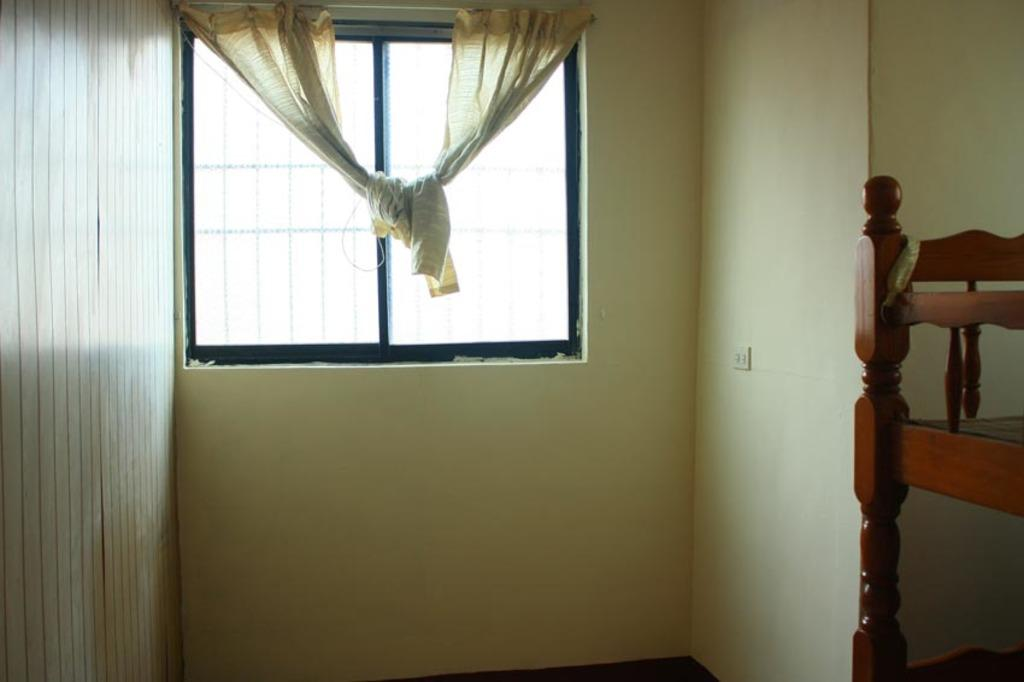What is located in the center of the image? There is a window in the center of the image. What else can be seen in the image? There is a wall in the image. Is there any window treatment present in the image? Yes, there is a curtain in the image. How many bikes are parked next to the wall in the image? There are no bikes present in the image. What is the writer doing in the image? There is no writer or any writing activity depicted in the image. 